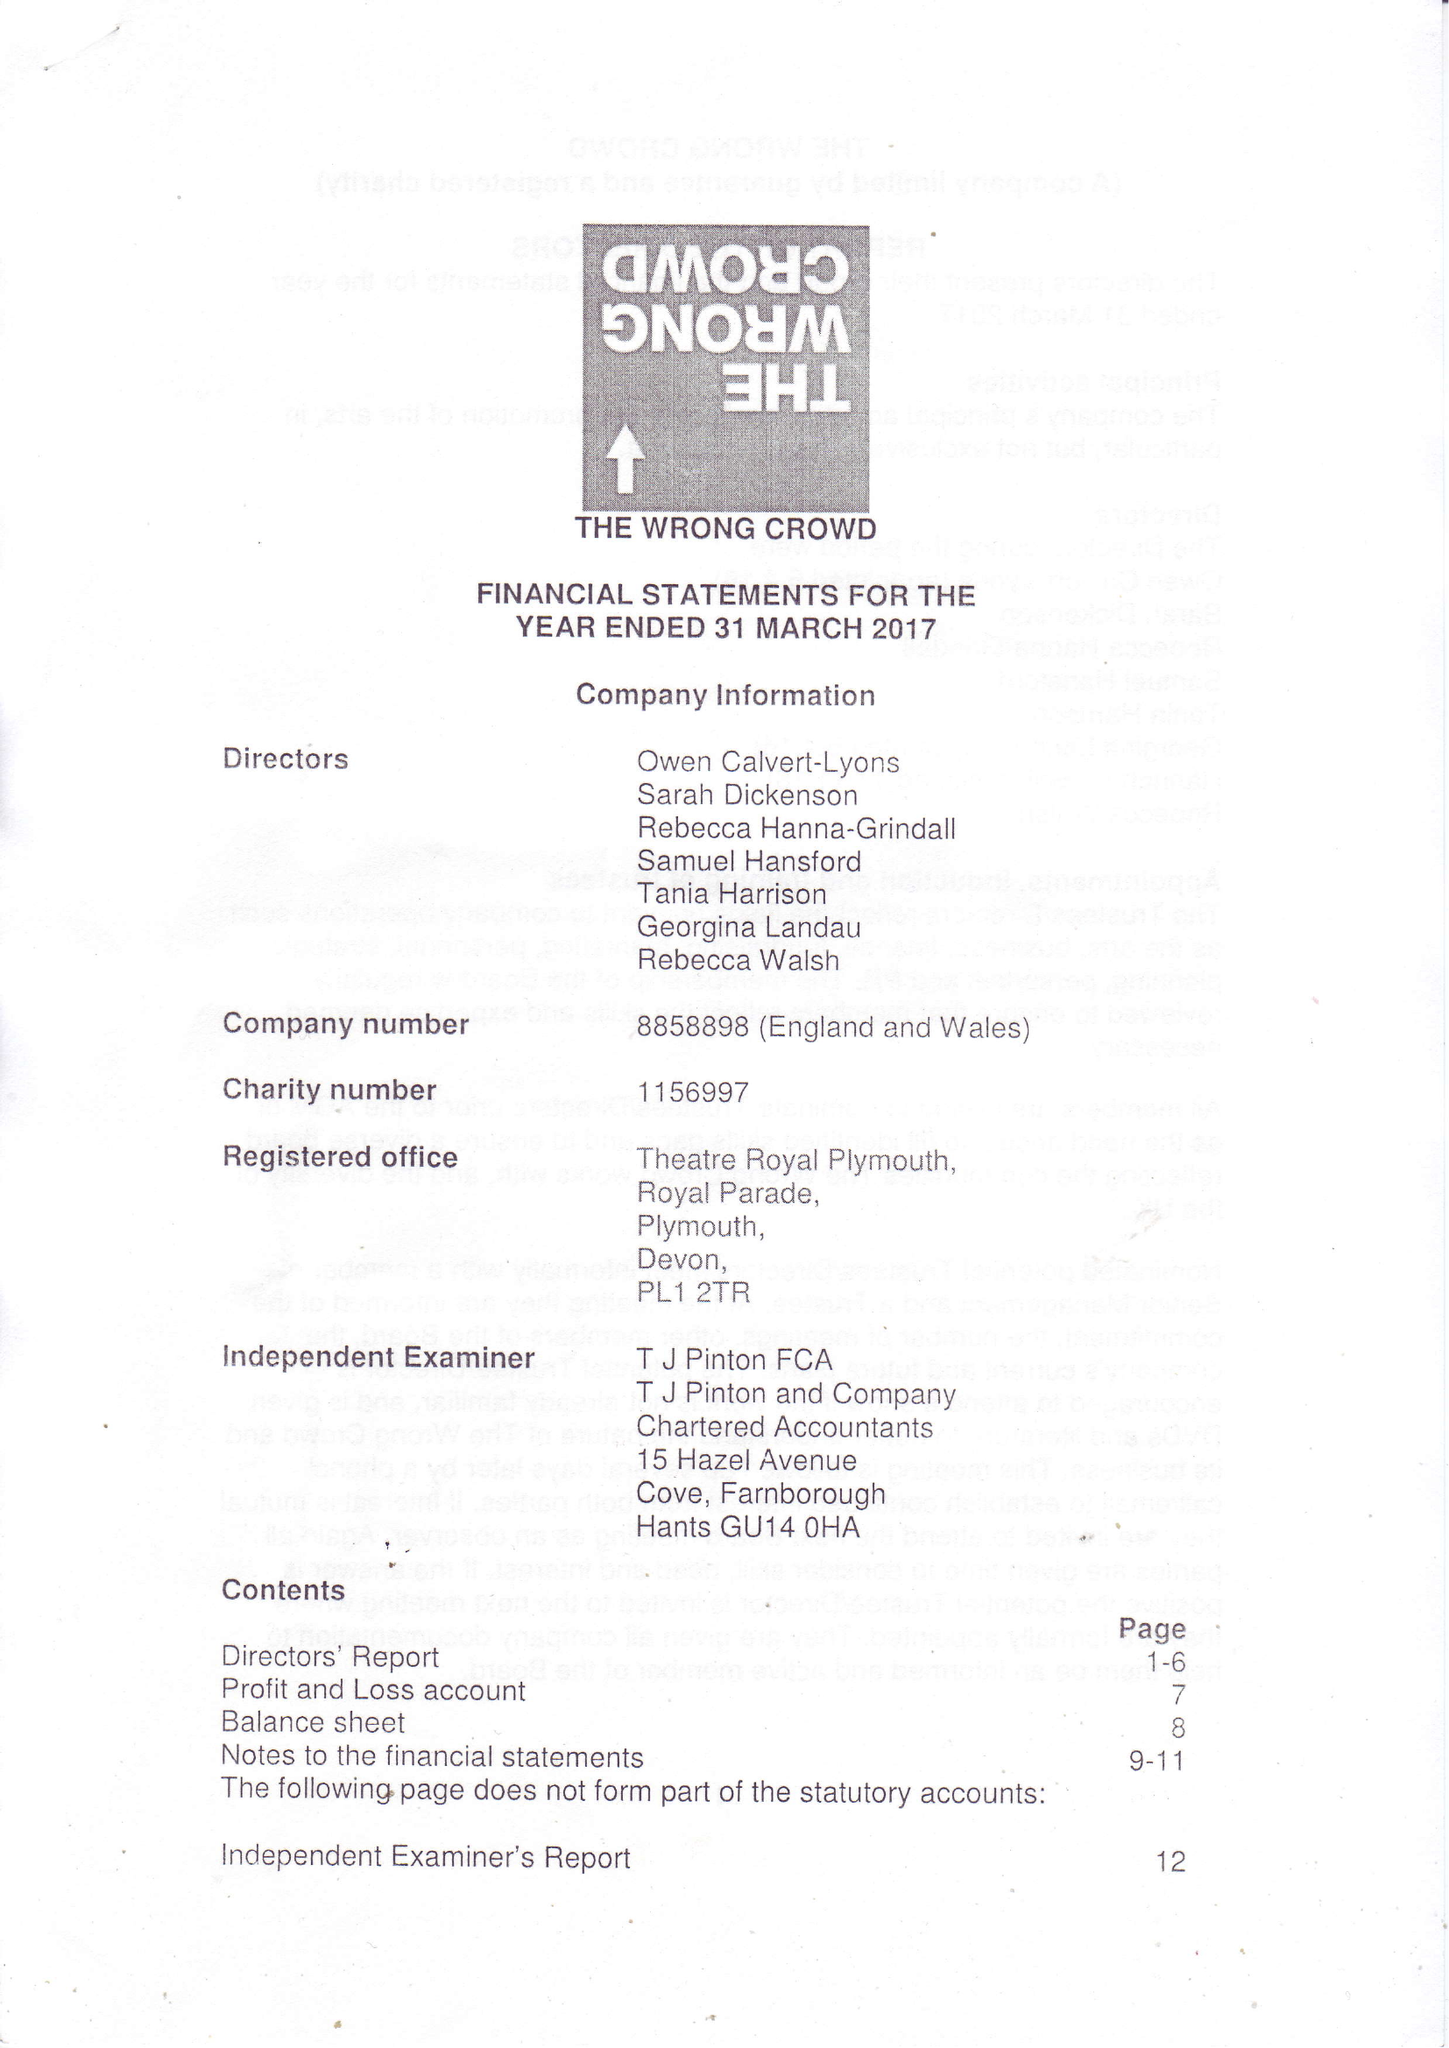What is the value for the charity_number?
Answer the question using a single word or phrase. 1156997 